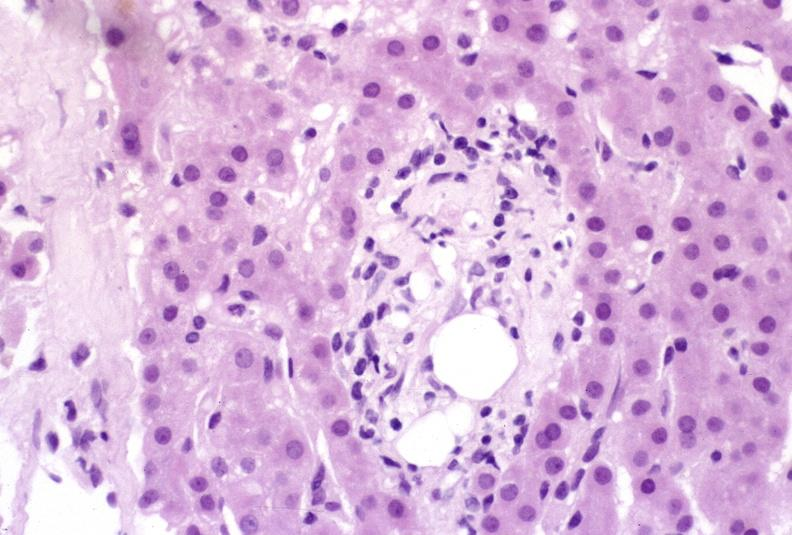s liver present?
Answer the question using a single word or phrase. Yes 